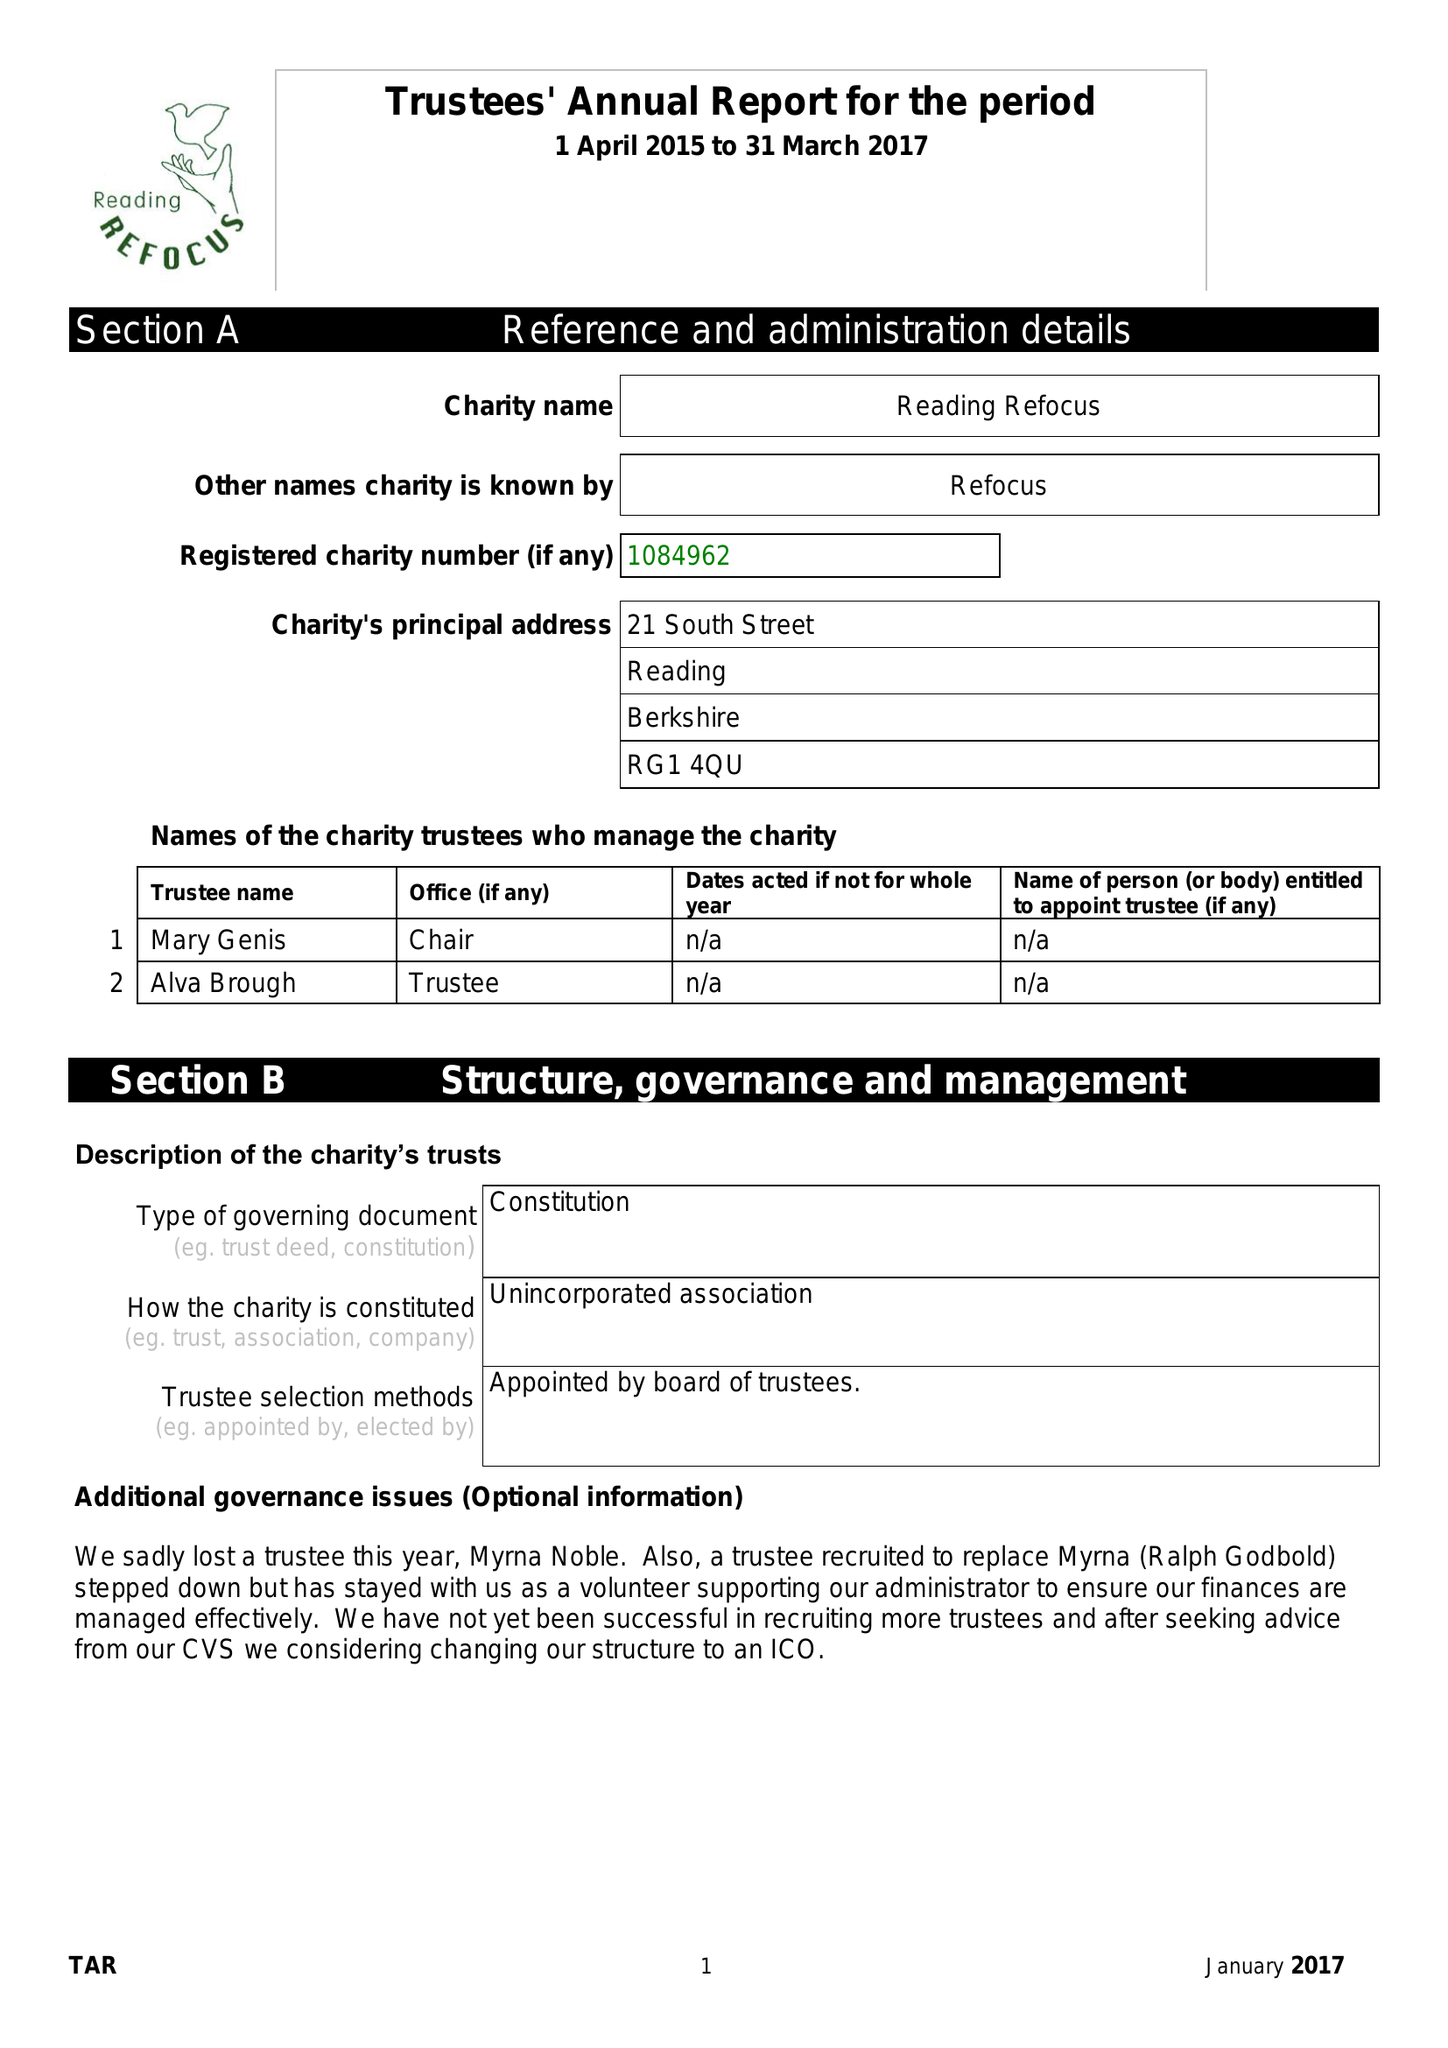What is the value for the report_date?
Answer the question using a single word or phrase. 2017-03-31 